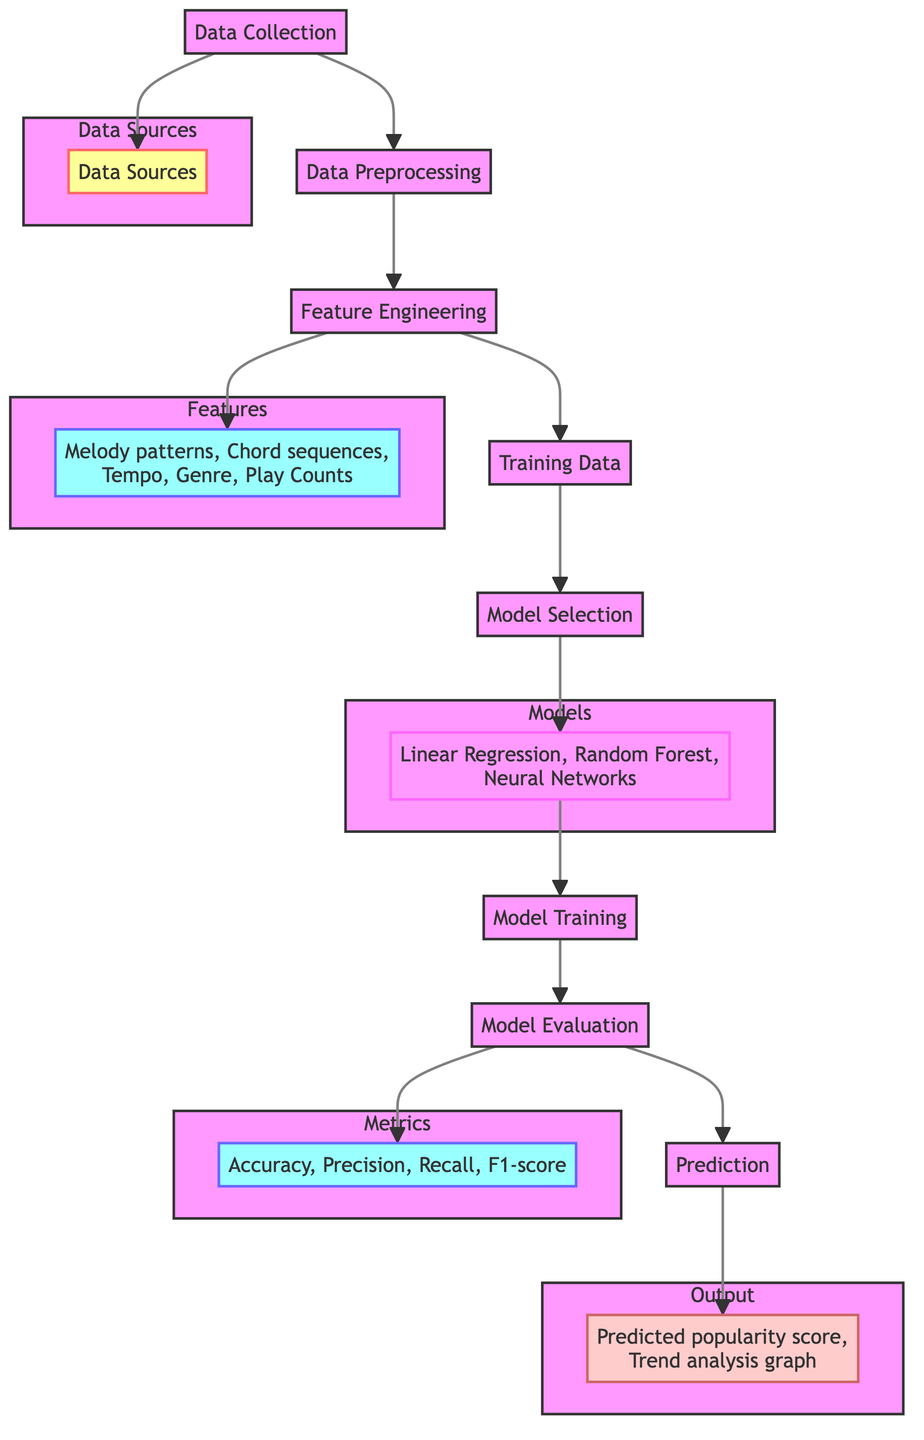What is the first step in the process? The first step in the diagram is "Data Collection," which is indicated at the beginning of the flowchart.
Answer: Data Collection How many data sources are there? The diagram represents only one "Data Sources" node under "Data Collection," which indicates that it encompasses various sources tied to the data collection.
Answer: One What does the "Feature Engineering" node lead to? The "Feature Engineering" node connects to both "Features" and "Training Data," showing that these outputs are derived from the feature engineering process.
Answer: Features and Training Data Which models are listed in the diagram? The diagram states "Linear Regression, Random Forest, Neural Networks" within the "Models" subgraph, indicating these are the algorithms considered for modeling.
Answer: Linear Regression, Random Forest, Neural Networks What metrics are used for model evaluation? The metrics listed for evaluation are "Accuracy, Precision, Recall, F1-score," highlighting the criteria for assessing model performance.
Answer: Accuracy, Precision, Recall, F1-score What is the ultimate output of the entire process? The final output from the entire process is captured in the "Output" node, which states "Predicted popularity score, Trend analysis graph."
Answer: Predicted popularity score, Trend analysis graph Which step occurs after model training? After "Model Training," the following step is "Model Evaluation," which assesses the trained model's performance based on various metrics.
Answer: Model Evaluation How many nodes are part of the "Models" subgraph? The "Models" subgraph contains one node, which covers three different modeling methods, representing them as a single entity in the diagram.
Answer: One Why is "Data Preprocessing" important before "Feature Engineering"? "Data Preprocessing" ensures that the data is clean and suitable for analysis, laying the foundation for effective "Feature Engineering" and ensuring that meaningful features are extracted correctly.
Answer: To ensure data cleanliness What is the relationship between "Model Evaluation" and "Prediction"? "Model Evaluation" leads to "Prediction," suggesting that the evaluation of the model's metrics is essential before making predictions about the data.
Answer: Evaluation leads to Prediction 